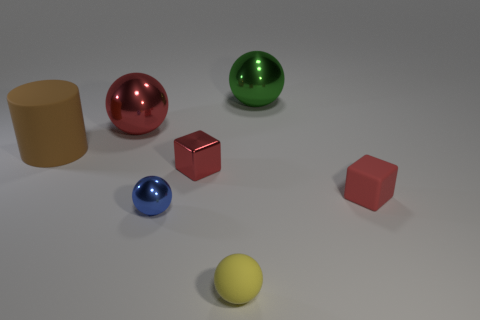Subtract 1 spheres. How many spheres are left? 3 Add 3 tiny brown rubber balls. How many objects exist? 10 Subtract all spheres. How many objects are left? 3 Subtract 0 cyan spheres. How many objects are left? 7 Subtract all tiny blocks. Subtract all big red shiny spheres. How many objects are left? 4 Add 5 tiny red shiny blocks. How many tiny red shiny blocks are left? 6 Add 3 metallic objects. How many metallic objects exist? 7 